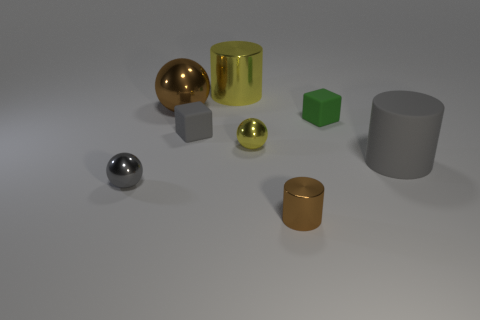Add 2 big brown rubber objects. How many objects exist? 10 Subtract all balls. How many objects are left? 5 Subtract 0 yellow blocks. How many objects are left? 8 Subtract all gray rubber blocks. Subtract all yellow balls. How many objects are left? 6 Add 2 large gray things. How many large gray things are left? 3 Add 6 big shiny cylinders. How many big shiny cylinders exist? 7 